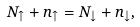Convert formula to latex. <formula><loc_0><loc_0><loc_500><loc_500>N _ { \uparrow } + n _ { \uparrow } = N _ { \downarrow } + n _ { \downarrow } ,</formula> 